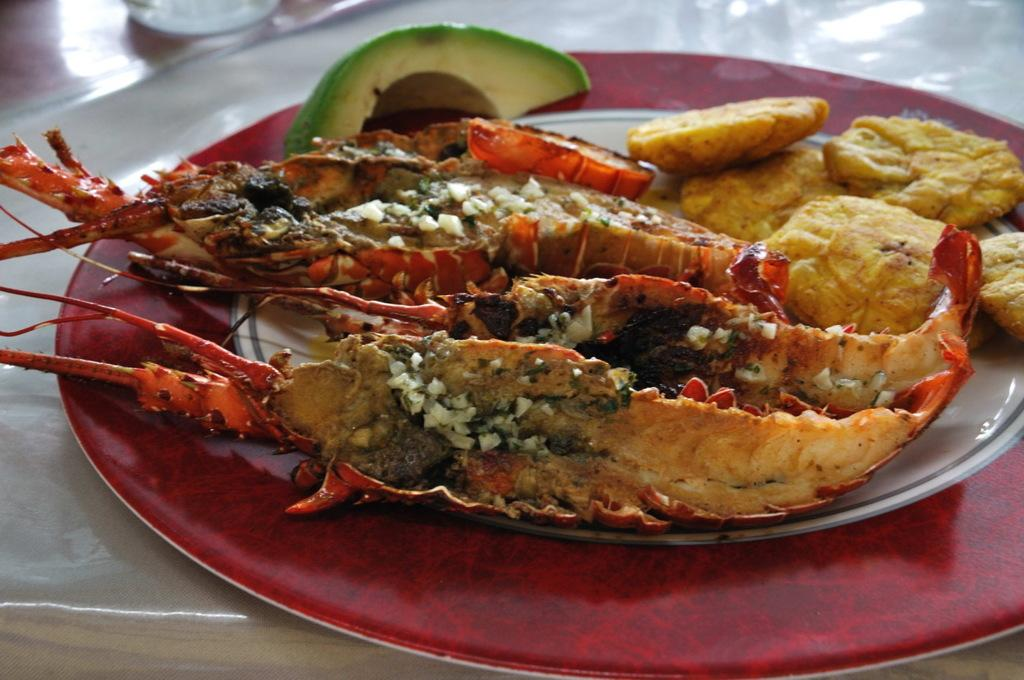What color combination is used for the plate in the image? The plate in the image is red and white. What is on the plate? The plate contains food. On what surface is the plate placed? The plate is placed on a white table. What type of fish can be seen swimming in the market during the holiday in the image? There is no fish, market, or holiday depicted in the image; it only features a red and white plate with food on a white table. 